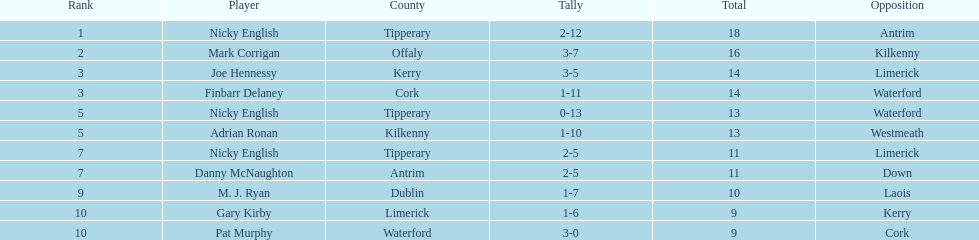How many points did joe hennessy and finbarr delaney each score? 14. 